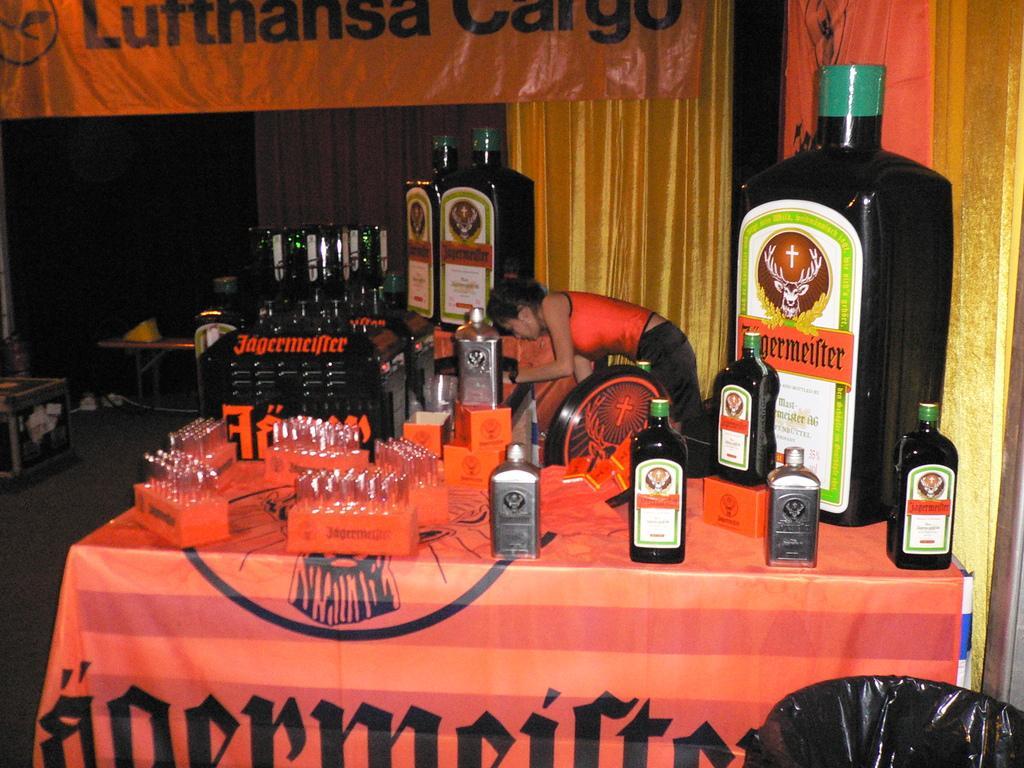Can you describe this image briefly? This is the table covered with cloth. These are the wine glasses placed on the red boxes. These are the bottles which are sealed with the metal caps. I can see a woman standing here. These are the bottles placed in an order. This looks like a cloth with a name on it. I think these are the curtains hanging. Here I can see a table with objects on ti. This looks like a dustbin. 